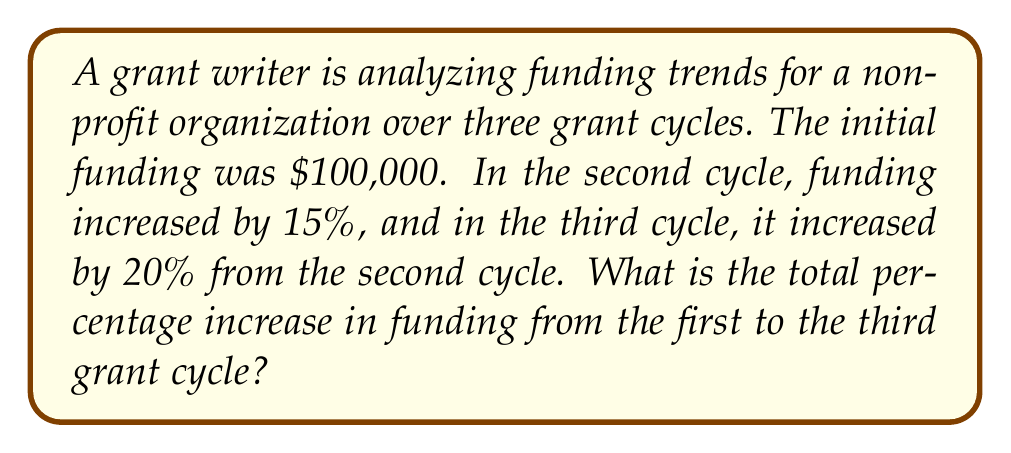Teach me how to tackle this problem. Let's approach this step-by-step:

1. Initial funding: $100,000

2. Second cycle funding:
   $100,000 * (1 + 0.15) = $100,000 * 1.15 = $115,000$

3. Third cycle funding:
   $115,000 * (1 + 0.20) = $115,000 * 1.20 = $138,000$

4. To calculate the total percentage increase, we use the formula:
   $\text{Percentage Increase} = \frac{\text{Final Value} - \text{Initial Value}}{\text{Initial Value}} * 100\%$

5. Plugging in our values:
   $\text{Percentage Increase} = \frac{138,000 - 100,000}{100,000} * 100\%$

6. Simplifying:
   $\text{Percentage Increase} = \frac{38,000}{100,000} * 100\% = 0.38 * 100\% = 38\%$

Therefore, the total percentage increase from the first to the third grant cycle is 38%.
Answer: 38% 